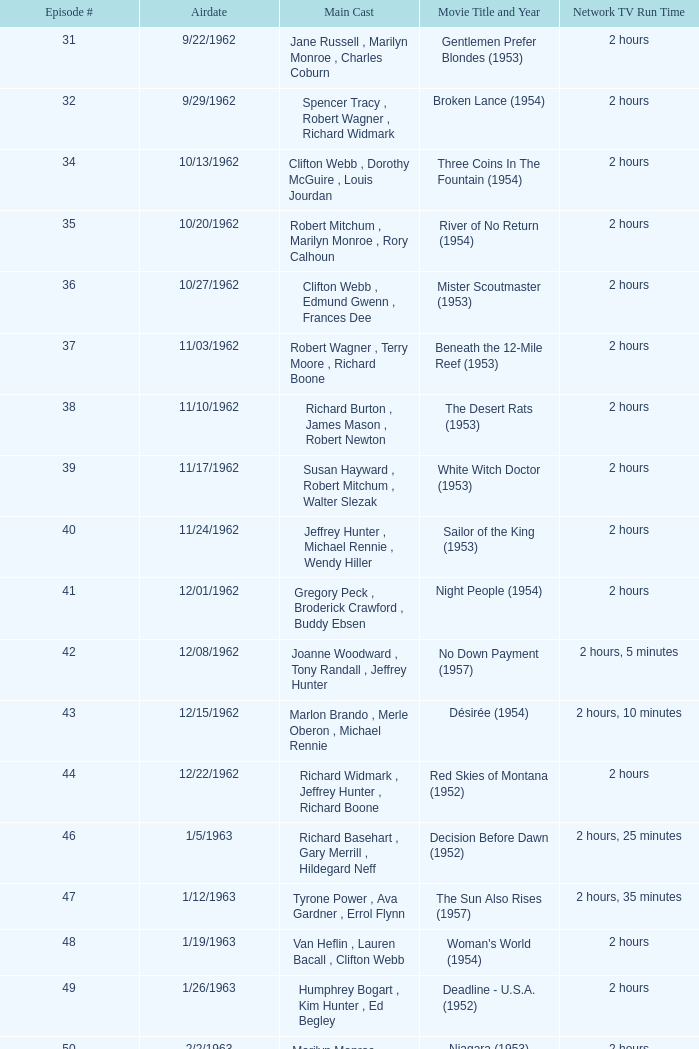Who was the cast on the 3/23/1963 episode? Dana Wynter , Mel Ferrer , Theodore Bikel. 